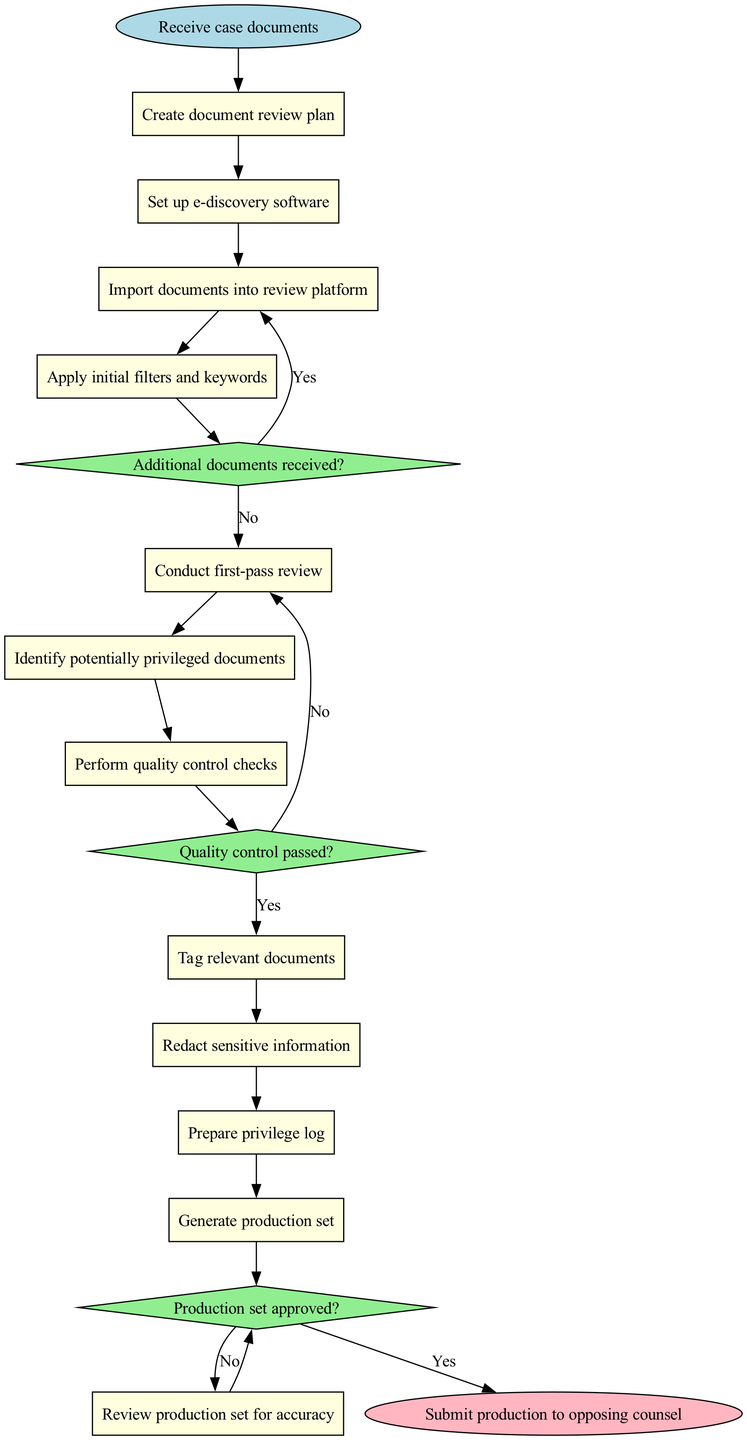What is the first activity node in the diagram? The first activity node is directly connected to the start node, which in this case specifies "Receive case documents" as the initial action taken in the process.
Answer: Receive case documents How many decision nodes are present in the diagram? By counting the diamond-shaped nodes in the diagram, we find three decision points where choices are made regarding the flow of the document review process.
Answer: 3 What is the last activity before submitting the production set? The last activity before reaching the end node is "Review production set for accuracy", which informs the final steps of submission.
Answer: Review production set for accuracy What happens if the quality control checks do not pass? If the quality control checks do not pass, the process flows back to "Conduct first-pass review", indicating that further review is necessary before moving forward.
Answer: Return to first-pass review What is the outcome if the production set is approved? If the production set is approved, the flow proceeds to finalize the production, indicating successful completion of a crucial step in the process.
Answer: Finalize production What is the activity that follows "Apply initial filters and keywords"? Immediately following "Apply initial filters and keywords", the next activity in the sequence is "Conduct first-pass review", which marks the start of the document evaluation.
Answer: Conduct first-pass review What does the diagram indicate if additional documents are received? When additional documents are received, the process directs to "Import documents into review platform", ensuring that all relevant materials are incorporated into the review process.
Answer: Import documents into review platform Which activity involves identifying documents with privileged information? The activity specifically designated for identifying potentially privileged documents is labeled as such and is situated after the first-pass review in the activity flow.
Answer: Identify potentially privileged documents 